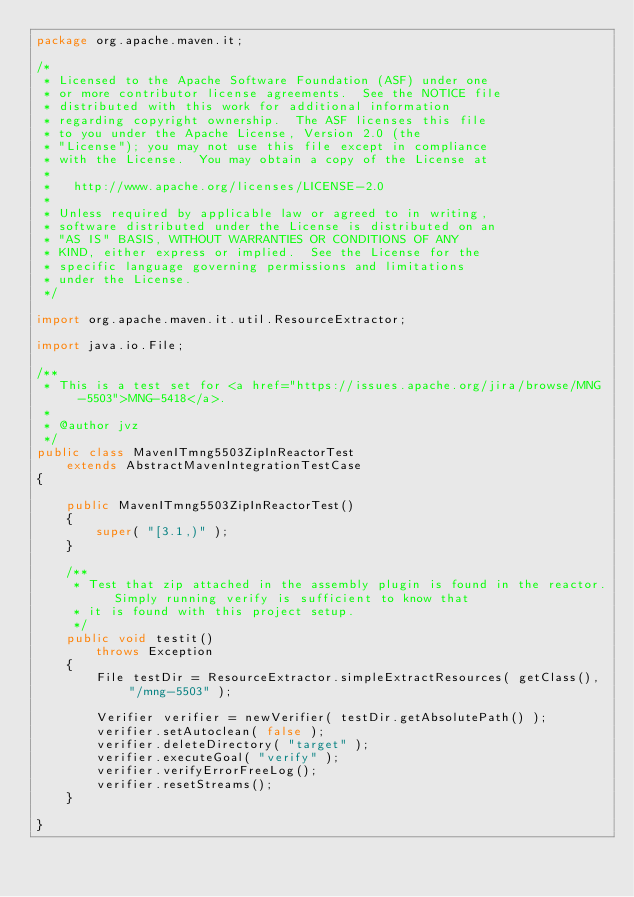<code> <loc_0><loc_0><loc_500><loc_500><_Java_>package org.apache.maven.it;

/*
 * Licensed to the Apache Software Foundation (ASF) under one
 * or more contributor license agreements.  See the NOTICE file
 * distributed with this work for additional information
 * regarding copyright ownership.  The ASF licenses this file
 * to you under the Apache License, Version 2.0 (the
 * "License"); you may not use this file except in compliance
 * with the License.  You may obtain a copy of the License at
 *
 *   http://www.apache.org/licenses/LICENSE-2.0
 *
 * Unless required by applicable law or agreed to in writing,
 * software distributed under the License is distributed on an
 * "AS IS" BASIS, WITHOUT WARRANTIES OR CONDITIONS OF ANY
 * KIND, either express or implied.  See the License for the
 * specific language governing permissions and limitations
 * under the License.
 */

import org.apache.maven.it.util.ResourceExtractor;

import java.io.File;

/**
 * This is a test set for <a href="https://issues.apache.org/jira/browse/MNG-5503">MNG-5418</a>.
 *
 * @author jvz
 */
public class MavenITmng5503ZipInReactorTest
    extends AbstractMavenIntegrationTestCase
{

    public MavenITmng5503ZipInReactorTest()
    {
        super( "[3.1,)" );
    }

    /**
     * Test that zip attached in the assembly plugin is found in the reactor. Simply running verify is sufficient to know that
     * it is found with this project setup.
     */
    public void testit()
        throws Exception
    {
        File testDir = ResourceExtractor.simpleExtractResources( getClass(), "/mng-5503" );

        Verifier verifier = newVerifier( testDir.getAbsolutePath() );
        verifier.setAutoclean( false );
        verifier.deleteDirectory( "target" );
        verifier.executeGoal( "verify" );
        verifier.verifyErrorFreeLog();
        verifier.resetStreams();
    }

}
</code> 